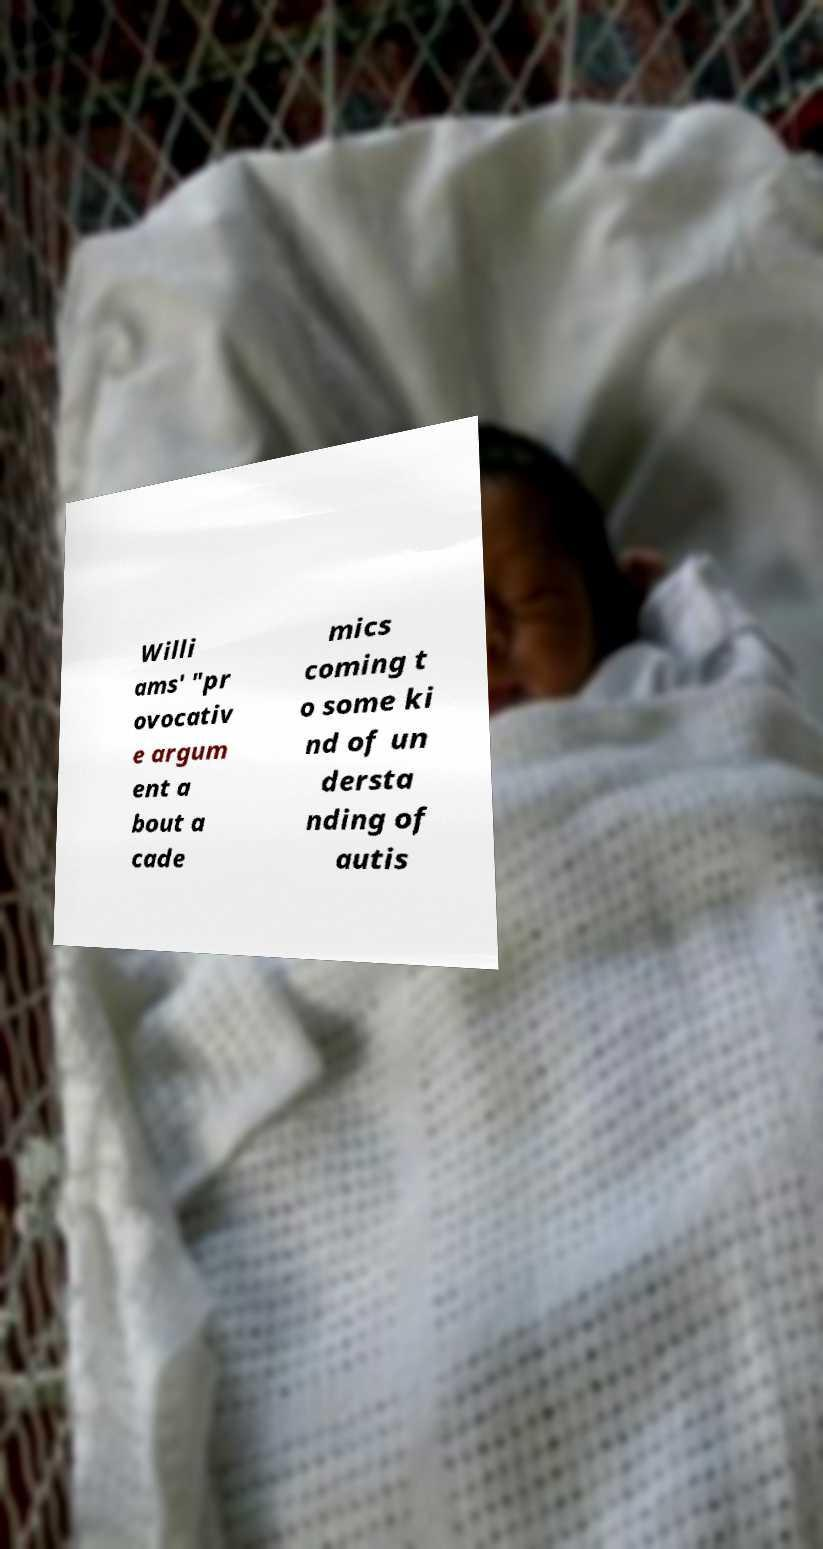There's text embedded in this image that I need extracted. Can you transcribe it verbatim? Willi ams' "pr ovocativ e argum ent a bout a cade mics coming t o some ki nd of un dersta nding of autis 